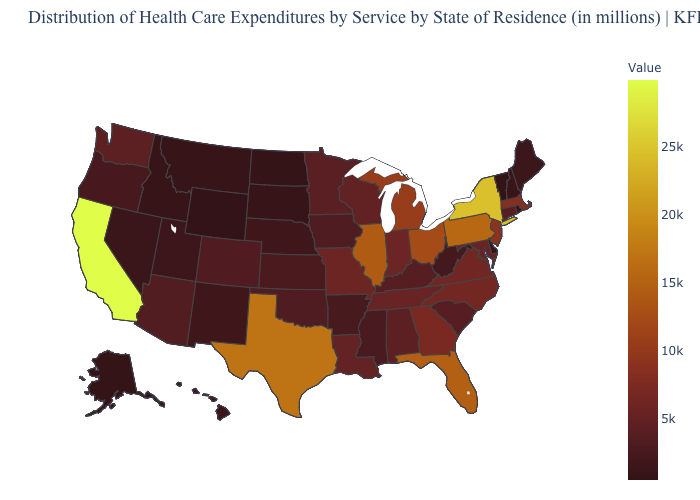Among the states that border Wyoming , which have the highest value?
Write a very short answer. Colorado. Does Wyoming have the lowest value in the West?
Concise answer only. Yes. Among the states that border Ohio , does West Virginia have the lowest value?
Keep it brief. Yes. Does Nevada have the highest value in the West?
Keep it brief. No. 